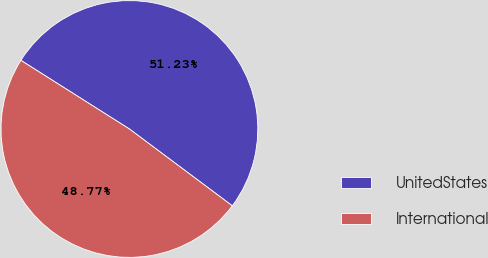Convert chart to OTSL. <chart><loc_0><loc_0><loc_500><loc_500><pie_chart><fcel>UnitedStates<fcel>International<nl><fcel>51.23%<fcel>48.77%<nl></chart> 